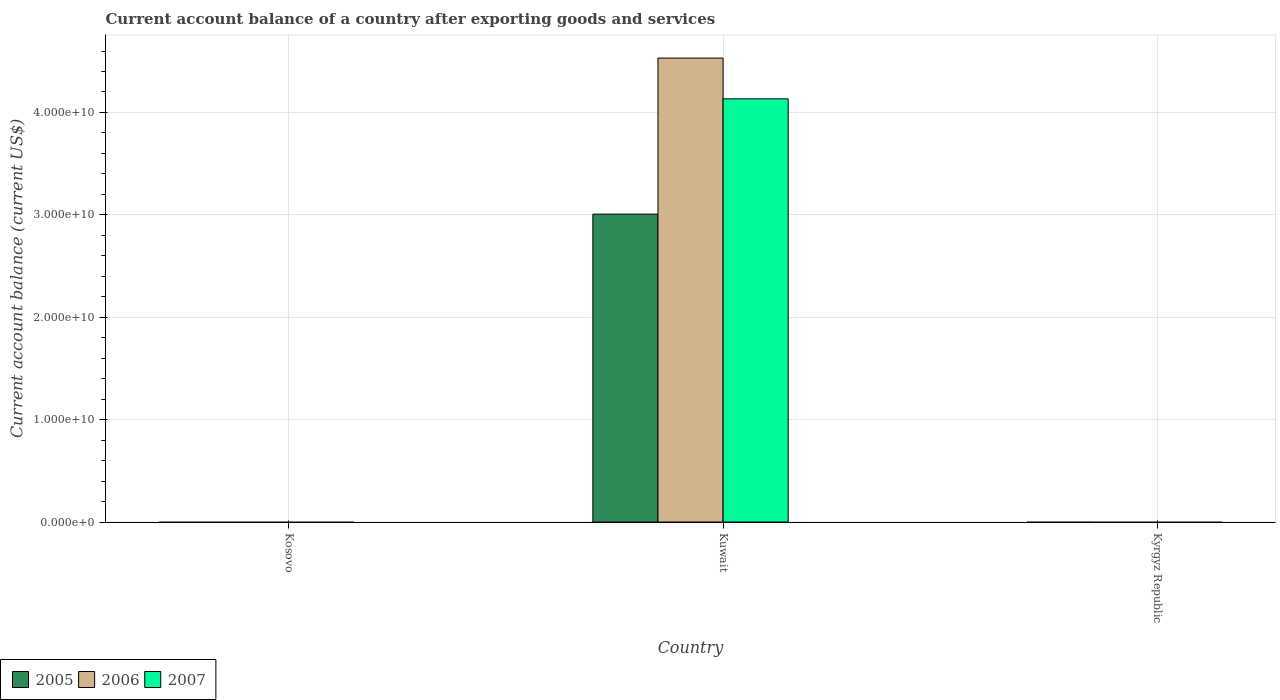How many bars are there on the 2nd tick from the left?
Offer a very short reply. 3. How many bars are there on the 1st tick from the right?
Your answer should be compact. 0. What is the label of the 1st group of bars from the left?
Provide a short and direct response. Kosovo. Across all countries, what is the maximum account balance in 2005?
Provide a succinct answer. 3.01e+1. In which country was the account balance in 2006 maximum?
Your response must be concise. Kuwait. What is the total account balance in 2005 in the graph?
Keep it short and to the point. 3.01e+1. What is the average account balance in 2006 per country?
Give a very brief answer. 1.51e+1. What is the difference between the account balance of/in 2007 and account balance of/in 2006 in Kuwait?
Your answer should be very brief. -3.98e+09. What is the difference between the highest and the lowest account balance in 2006?
Offer a terse response. 4.53e+1. In how many countries, is the account balance in 2006 greater than the average account balance in 2006 taken over all countries?
Provide a short and direct response. 1. Is it the case that in every country, the sum of the account balance in 2006 and account balance in 2007 is greater than the account balance in 2005?
Ensure brevity in your answer.  No. How many bars are there?
Provide a short and direct response. 3. Are all the bars in the graph horizontal?
Keep it short and to the point. No. Are the values on the major ticks of Y-axis written in scientific E-notation?
Your answer should be compact. Yes. Does the graph contain any zero values?
Ensure brevity in your answer.  Yes. How many legend labels are there?
Ensure brevity in your answer.  3. What is the title of the graph?
Provide a short and direct response. Current account balance of a country after exporting goods and services. What is the label or title of the Y-axis?
Keep it short and to the point. Current account balance (current US$). What is the Current account balance (current US$) in 2005 in Kuwait?
Your answer should be compact. 3.01e+1. What is the Current account balance (current US$) in 2006 in Kuwait?
Offer a terse response. 4.53e+1. What is the Current account balance (current US$) of 2007 in Kuwait?
Keep it short and to the point. 4.13e+1. Across all countries, what is the maximum Current account balance (current US$) in 2005?
Make the answer very short. 3.01e+1. Across all countries, what is the maximum Current account balance (current US$) of 2006?
Provide a succinct answer. 4.53e+1. Across all countries, what is the maximum Current account balance (current US$) of 2007?
Give a very brief answer. 4.13e+1. Across all countries, what is the minimum Current account balance (current US$) in 2005?
Ensure brevity in your answer.  0. What is the total Current account balance (current US$) of 2005 in the graph?
Make the answer very short. 3.01e+1. What is the total Current account balance (current US$) of 2006 in the graph?
Your answer should be very brief. 4.53e+1. What is the total Current account balance (current US$) of 2007 in the graph?
Offer a terse response. 4.13e+1. What is the average Current account balance (current US$) in 2005 per country?
Give a very brief answer. 1.00e+1. What is the average Current account balance (current US$) in 2006 per country?
Your response must be concise. 1.51e+1. What is the average Current account balance (current US$) in 2007 per country?
Ensure brevity in your answer.  1.38e+1. What is the difference between the Current account balance (current US$) in 2005 and Current account balance (current US$) in 2006 in Kuwait?
Offer a terse response. -1.52e+1. What is the difference between the Current account balance (current US$) in 2005 and Current account balance (current US$) in 2007 in Kuwait?
Keep it short and to the point. -1.13e+1. What is the difference between the Current account balance (current US$) of 2006 and Current account balance (current US$) of 2007 in Kuwait?
Give a very brief answer. 3.98e+09. What is the difference between the highest and the lowest Current account balance (current US$) in 2005?
Your answer should be compact. 3.01e+1. What is the difference between the highest and the lowest Current account balance (current US$) in 2006?
Offer a terse response. 4.53e+1. What is the difference between the highest and the lowest Current account balance (current US$) in 2007?
Your answer should be compact. 4.13e+1. 